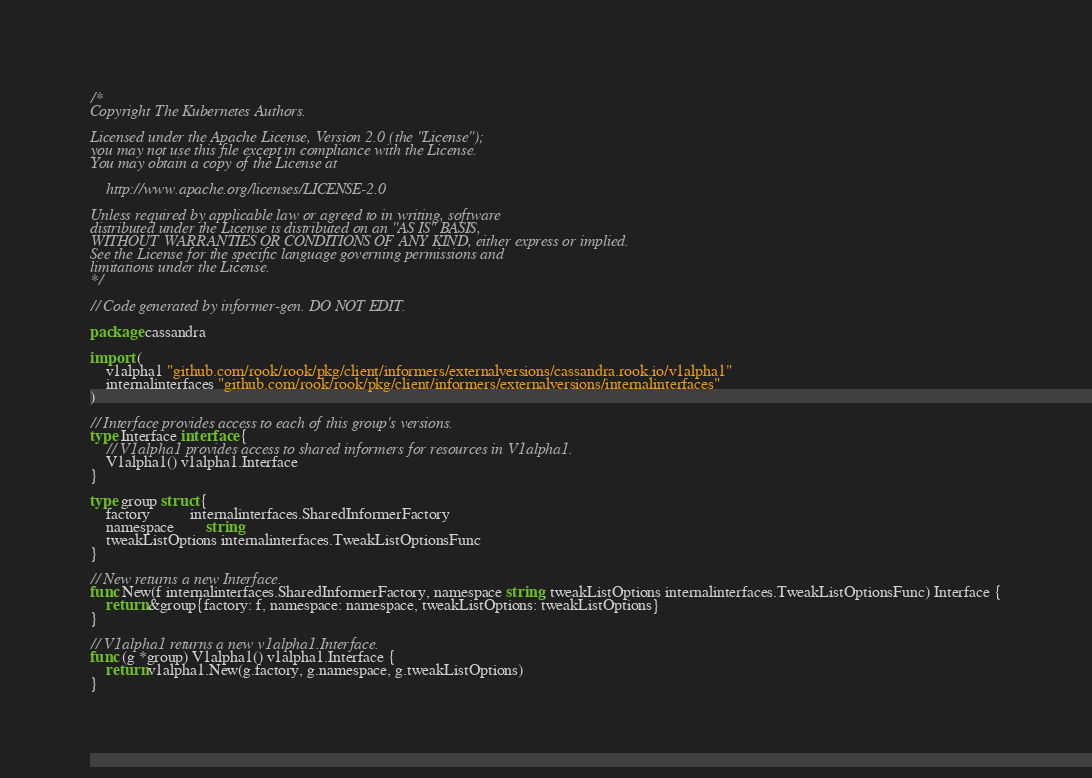<code> <loc_0><loc_0><loc_500><loc_500><_Go_>/*
Copyright The Kubernetes Authors.

Licensed under the Apache License, Version 2.0 (the "License");
you may not use this file except in compliance with the License.
You may obtain a copy of the License at

    http://www.apache.org/licenses/LICENSE-2.0

Unless required by applicable law or agreed to in writing, software
distributed under the License is distributed on an "AS IS" BASIS,
WITHOUT WARRANTIES OR CONDITIONS OF ANY KIND, either express or implied.
See the License for the specific language governing permissions and
limitations under the License.
*/

// Code generated by informer-gen. DO NOT EDIT.

package cassandra

import (
	v1alpha1 "github.com/rook/rook/pkg/client/informers/externalversions/cassandra.rook.io/v1alpha1"
	internalinterfaces "github.com/rook/rook/pkg/client/informers/externalversions/internalinterfaces"
)

// Interface provides access to each of this group's versions.
type Interface interface {
	// V1alpha1 provides access to shared informers for resources in V1alpha1.
	V1alpha1() v1alpha1.Interface
}

type group struct {
	factory          internalinterfaces.SharedInformerFactory
	namespace        string
	tweakListOptions internalinterfaces.TweakListOptionsFunc
}

// New returns a new Interface.
func New(f internalinterfaces.SharedInformerFactory, namespace string, tweakListOptions internalinterfaces.TweakListOptionsFunc) Interface {
	return &group{factory: f, namespace: namespace, tweakListOptions: tweakListOptions}
}

// V1alpha1 returns a new v1alpha1.Interface.
func (g *group) V1alpha1() v1alpha1.Interface {
	return v1alpha1.New(g.factory, g.namespace, g.tweakListOptions)
}
</code> 